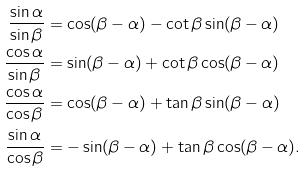Convert formula to latex. <formula><loc_0><loc_0><loc_500><loc_500>\frac { \sin \alpha } { \sin \beta } & = \cos ( \beta - \alpha ) - \cot \beta \sin ( \beta - \alpha ) \\ \frac { \cos \alpha } { \sin \beta } & = \sin ( \beta - \alpha ) + \cot \beta \cos ( \beta - \alpha ) \\ \frac { \cos \alpha } { \cos \beta } & = \cos ( \beta - \alpha ) + \tan \beta \sin ( \beta - \alpha ) \\ \frac { \sin \alpha } { \cos \beta } & = - \sin ( \beta - \alpha ) + \tan \beta \cos ( \beta - \alpha ) .</formula> 